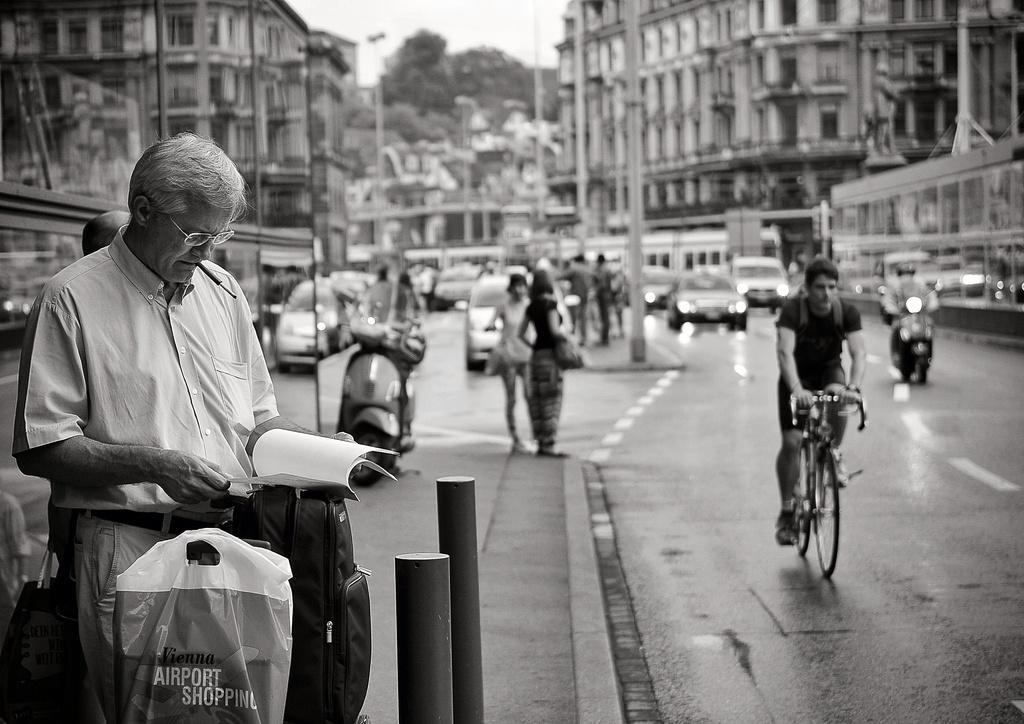Can you describe this image briefly? In this image i can see a man wearing a white shirt and pant standing and holding a book, bag and cover in his hands. In the background i can see few people standing on the sidewalk, few vehicles and a person riding the bicycle. I can see few buildings , few trees and the sky in the background. 